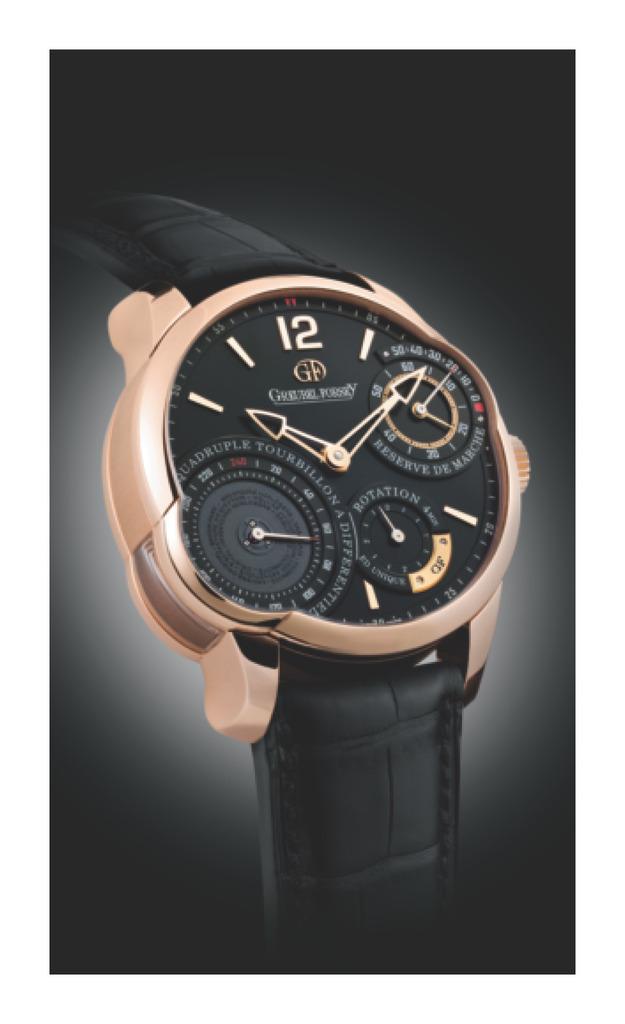What number is at the top of the watch?
Provide a succinct answer. 12. 